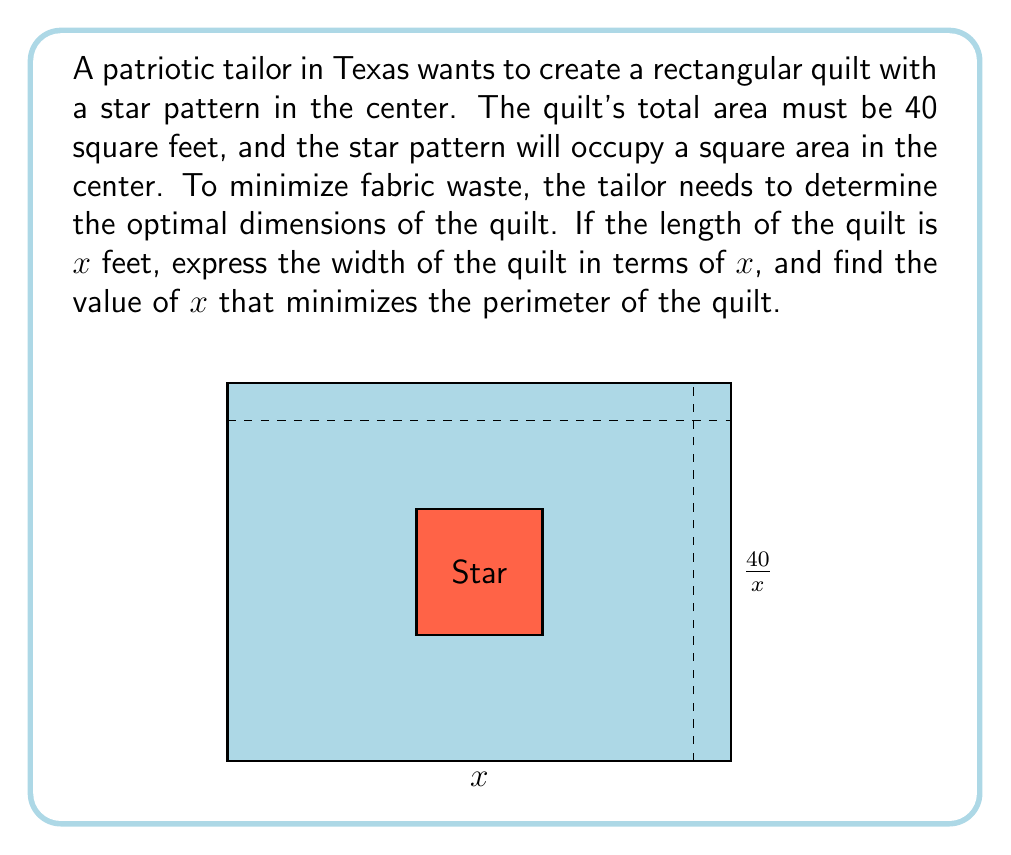Provide a solution to this math problem. Let's approach this step-by-step:

1) Given that the total area of the quilt is 40 square feet, and the length is $x$ feet, we can express the width in terms of $x$:

   Area = length × width
   $40 = x \times width$
   $width = \frac{40}{x}$

2) The perimeter of the rectangle is given by:
   $P = 2x + 2(\frac{40}{x})$

3) To find the minimum value of P, we need to find where its derivative equals zero:

   $\frac{dP}{dx} = 2 - \frac{80}{x^2}$

4) Set this equal to zero and solve for x:

   $2 - \frac{80}{x^2} = 0$
   $\frac{80}{x^2} = 2$
   $80 = 2x^2$
   $x^2 = 40$
   $x = \sqrt{40} = 2\sqrt{10}$

5) To confirm this is a minimum, we can check the second derivative:

   $\frac{d^2P}{dx^2} = \frac{160}{x^3}$

   This is always positive for positive x, confirming a minimum.

6) Therefore, the optimal length of the quilt is $2\sqrt{10}$ feet, and the optimal width is:

   $width = \frac{40}{2\sqrt{10}} = 2\sqrt{10}$ feet

The quilt should be a square for minimum perimeter.
Answer: $x = 2\sqrt{10}$ feet 